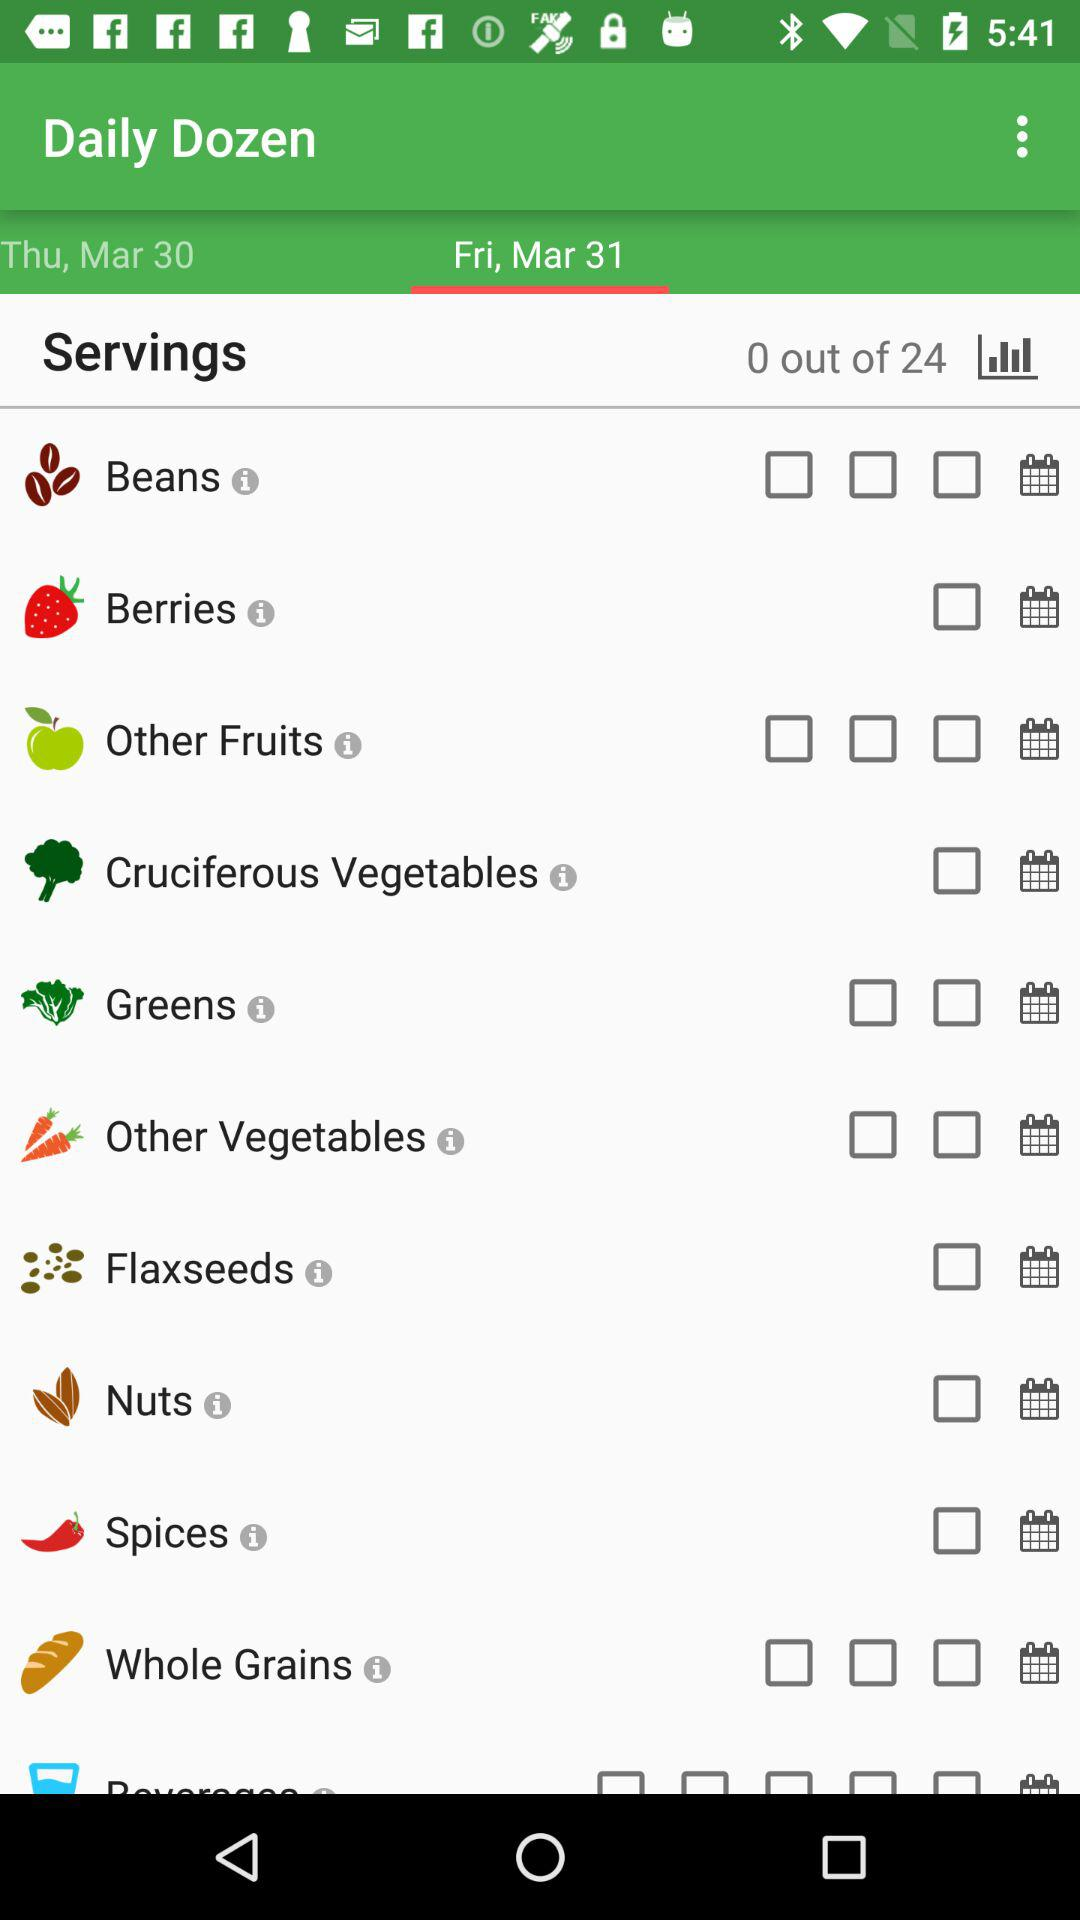What is the selected date? The selected day is Friday, March 31. 